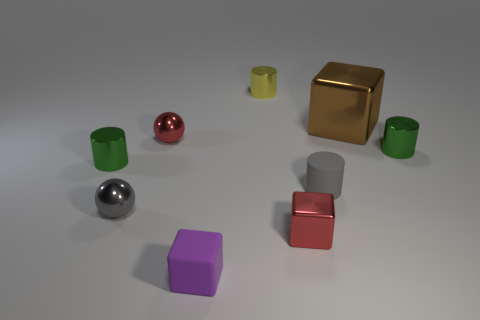What is the material of the small sphere that is the same color as the small matte cylinder?
Offer a terse response. Metal. Are there any other things that are the same shape as the yellow object?
Provide a short and direct response. Yes. Does the red metal cube have the same size as the gray cylinder?
Offer a terse response. Yes. The cylinder that is on the left side of the tiny red metal thing on the left side of the red thing to the right of the small purple object is made of what material?
Offer a very short reply. Metal. Is the number of green shiny objects on the right side of the purple thing the same as the number of matte cubes?
Offer a terse response. Yes. Are there any other things that are the same size as the yellow thing?
Give a very brief answer. Yes. How many things are red rubber cylinders or large brown objects?
Give a very brief answer. 1. There is a big brown object that is the same material as the small gray ball; what is its shape?
Provide a short and direct response. Cube. What size is the cube that is on the left side of the tiny cube behind the matte block?
Offer a terse response. Small. What number of tiny things are blue shiny spheres or green objects?
Your response must be concise. 2. 